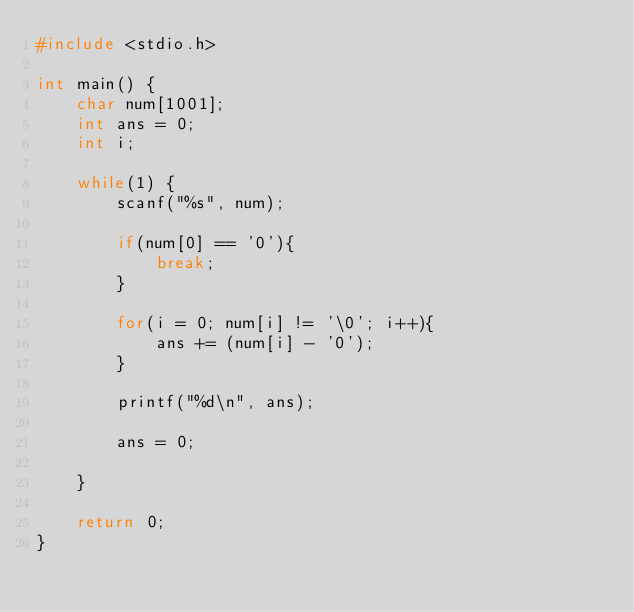<code> <loc_0><loc_0><loc_500><loc_500><_C_>#include <stdio.h>

int main() {
    char num[1001];
    int ans = 0;
    int i;
    
    while(1) {
        scanf("%s", num);
        
        if(num[0] == '0'){
            break;
        }
        
        for(i = 0; num[i] != '\0'; i++){
            ans += (num[i] - '0');
        }
        
        printf("%d\n", ans);
        
        ans = 0;
        
    }
    
    return 0;
}

</code> 